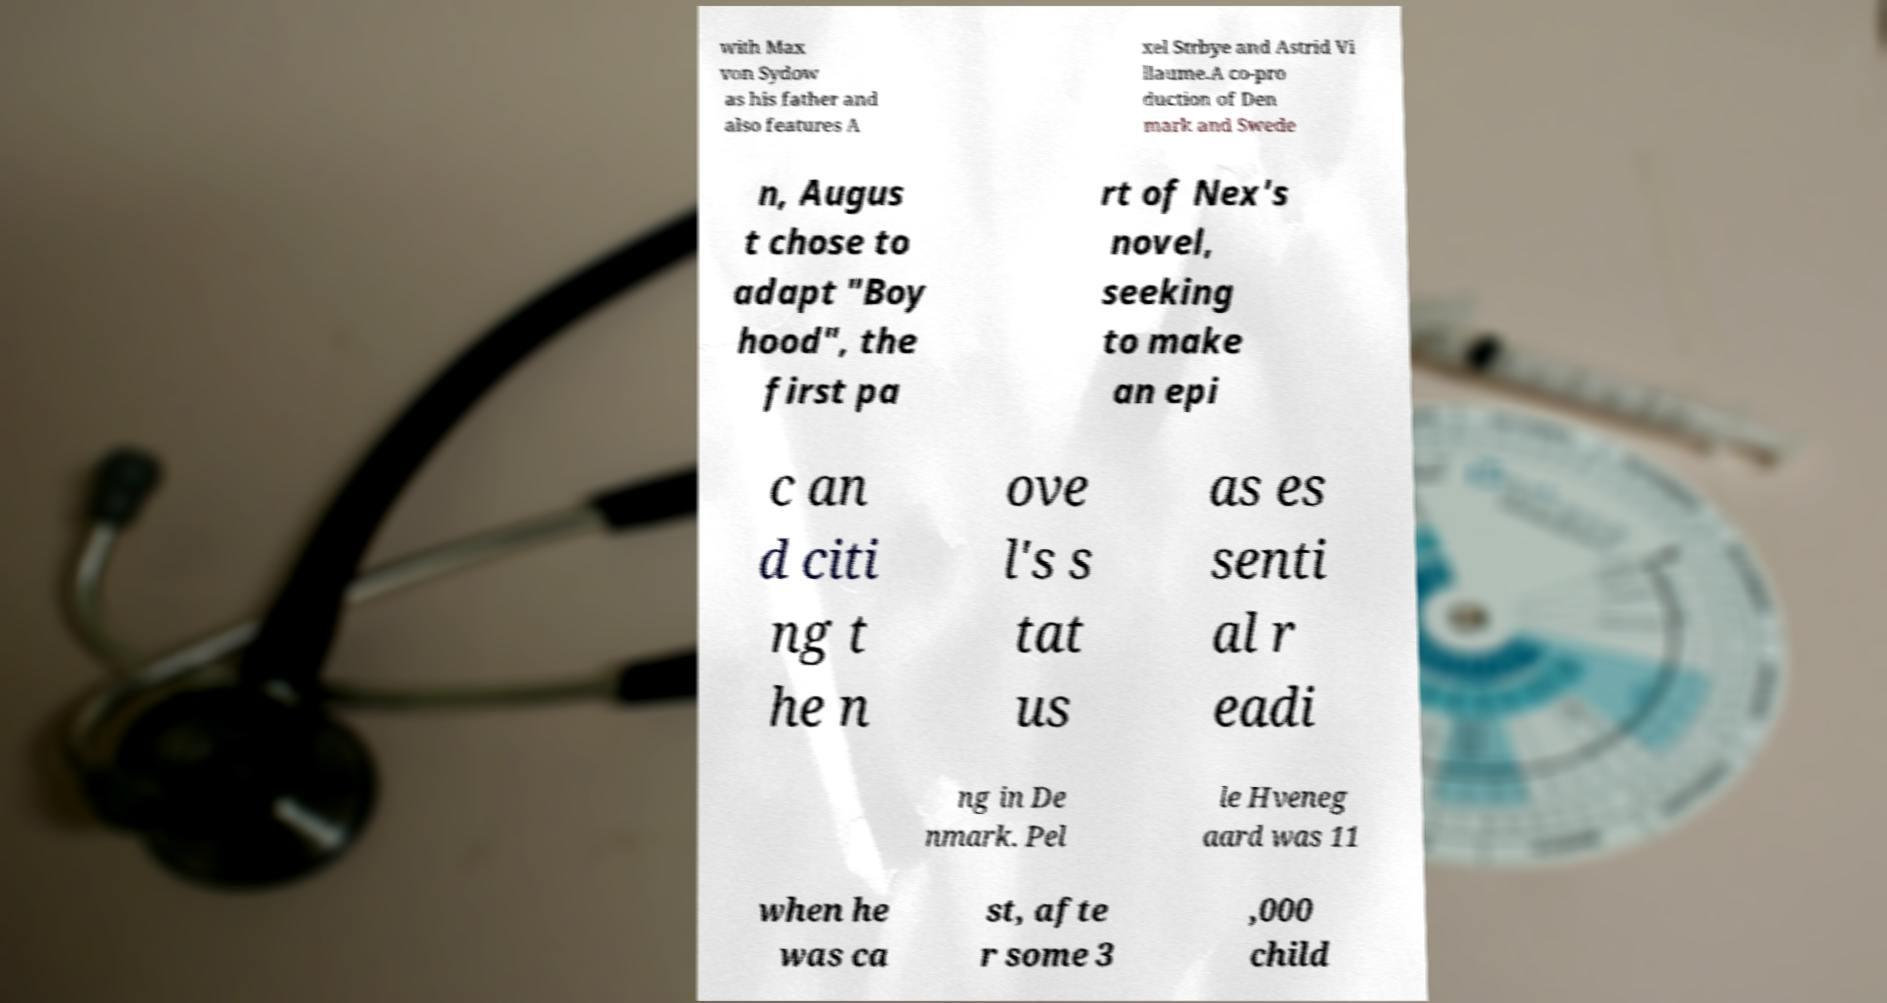What messages or text are displayed in this image? I need them in a readable, typed format. with Max von Sydow as his father and also features A xel Strbye and Astrid Vi llaume.A co-pro duction of Den mark and Swede n, Augus t chose to adapt "Boy hood", the first pa rt of Nex's novel, seeking to make an epi c an d citi ng t he n ove l's s tat us as es senti al r eadi ng in De nmark. Pel le Hveneg aard was 11 when he was ca st, afte r some 3 ,000 child 